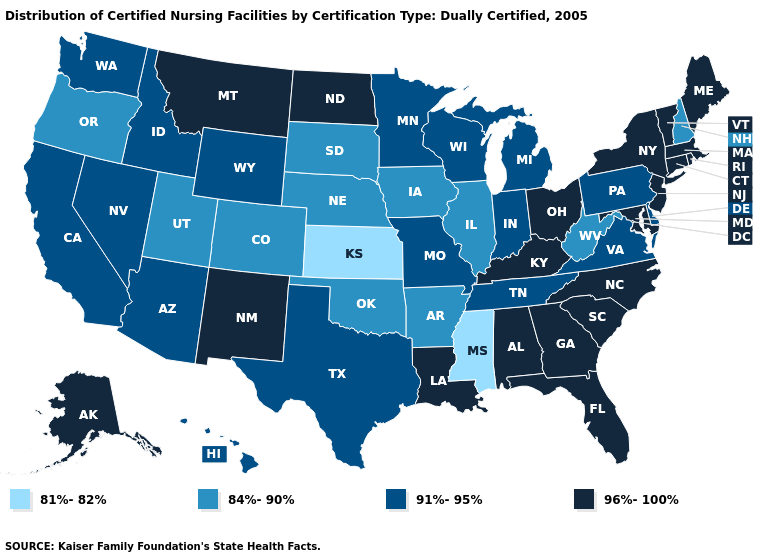What is the value of Missouri?
Give a very brief answer. 91%-95%. Among the states that border Wyoming , which have the lowest value?
Answer briefly. Colorado, Nebraska, South Dakota, Utah. What is the highest value in the USA?
Concise answer only. 96%-100%. What is the value of Oregon?
Give a very brief answer. 84%-90%. Is the legend a continuous bar?
Give a very brief answer. No. Does Michigan have a higher value than Tennessee?
Quick response, please. No. What is the value of Wyoming?
Be succinct. 91%-95%. What is the value of Utah?
Give a very brief answer. 84%-90%. Among the states that border Montana , which have the lowest value?
Be succinct. South Dakota. Which states hav the highest value in the South?
Write a very short answer. Alabama, Florida, Georgia, Kentucky, Louisiana, Maryland, North Carolina, South Carolina. Name the states that have a value in the range 81%-82%?
Answer briefly. Kansas, Mississippi. Name the states that have a value in the range 84%-90%?
Concise answer only. Arkansas, Colorado, Illinois, Iowa, Nebraska, New Hampshire, Oklahoma, Oregon, South Dakota, Utah, West Virginia. Name the states that have a value in the range 81%-82%?
Concise answer only. Kansas, Mississippi. Name the states that have a value in the range 81%-82%?
Be succinct. Kansas, Mississippi. Does New Hampshire have the highest value in the Northeast?
Quick response, please. No. 